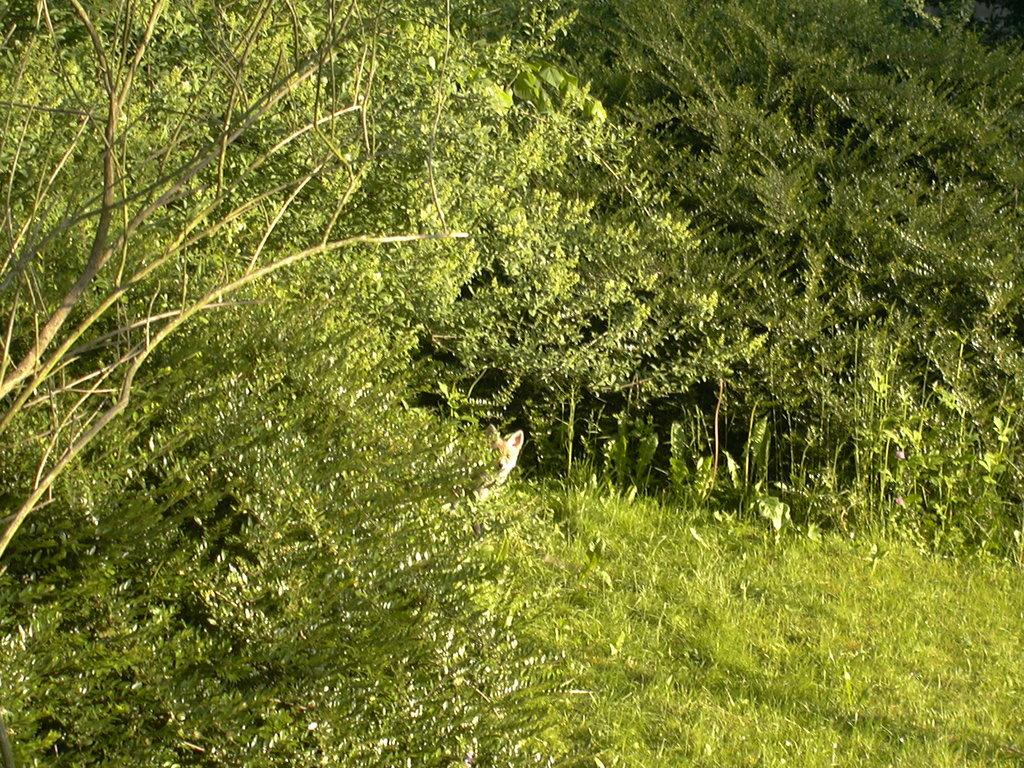What is located in the center of the image? There are trees in the center of the image. What type of living organism can be seen in the image? There is an animal visible in the image. What type of vegetation is at the bottom of the image? There is grass at the bottom of the image. What type of basketball skills does the laborer demonstrate in the image? There is no laborer or basketball present in the image. What type of advice does the uncle give to the animal in the image? There is no uncle present in the image, and therefore no such interaction can be observed. 